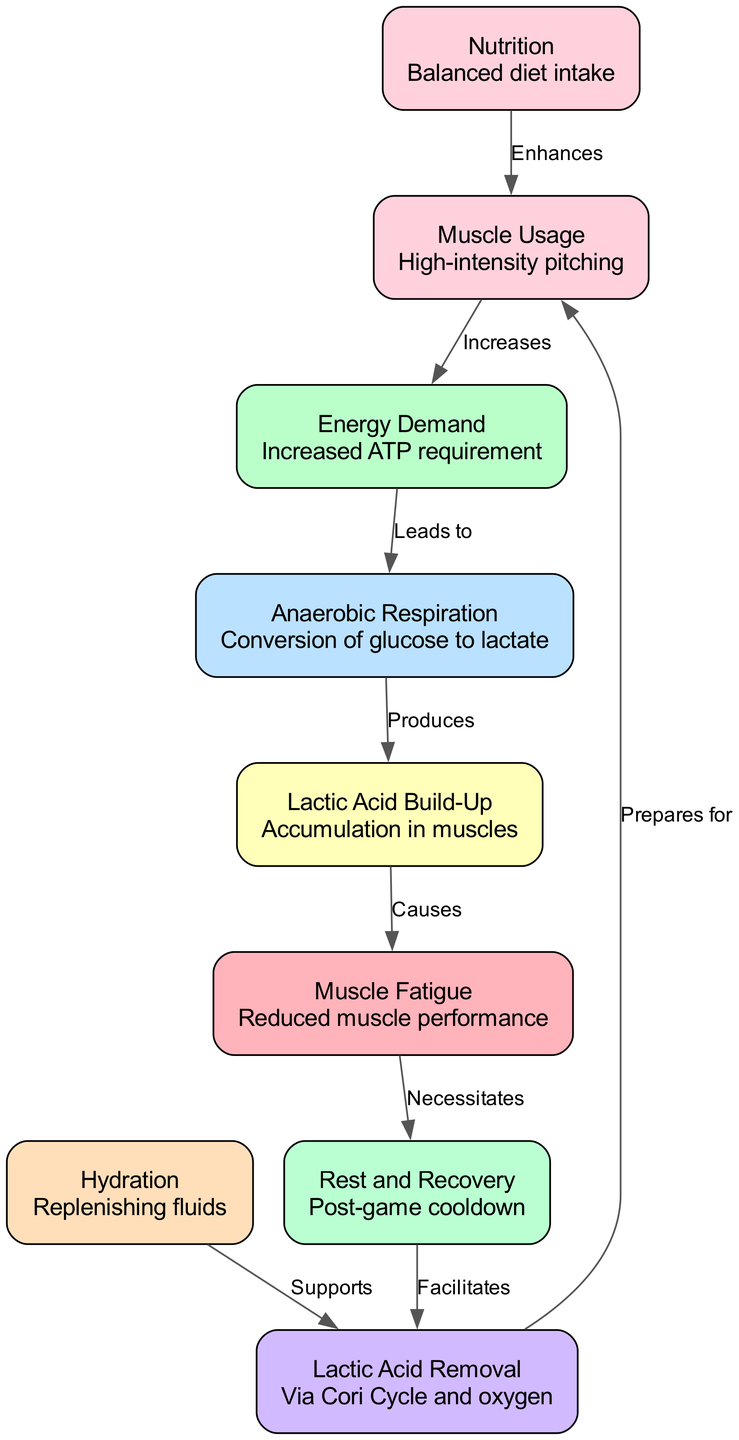What is the first node in the diagram? The first node is "Muscle Usage," which represents high-intensity pitching. The nodes are presented in an order defined by the relationships illustrated in the edges.
Answer: Muscle Usage How many nodes are in the diagram? The diagram contains 9 nodes that represent different aspects of muscle fatigue and recovery related to baseball pitchers. Each node corresponds to a unique concept in the process illustrated.
Answer: 9 What causes lactic acid build-up? Lactic acid build-up is caused by anaerobic respiration, which is the conversion of glucose to lactate during high-energy demands in muscle usage. The arrows in the diagram indicate the flow of influence leading to lactic acid formation.
Answer: Anaerobic Respiration What supports lactic acid clearance? Lactic acid clearance is supported by hydration, which aids in the process of removing lactic acid from the muscles. The diagram explicitly connects these two nodes, showing their relationship.
Answer: Hydration What is produced from anaerobic respiration? Anaerobic respiration produces lactic acid as a byproduct when glucose is converted under high-energy demand conditions during pitching. This is highlighted in the diagram showing the flow from anaerobic respiration to lactic acid.
Answer: Lactic Acid How does rest and recovery relate to muscle fatigue? Rest and recovery is necessitated by muscle fatigue, indicating that when muscle fatigue occurs, it is essential to allow time for rest and recovery to facilitate the clearance process and prepare for further muscle usage. The relationship is depicted by the arrow connecting these two nodes.
Answer: Necessitates Which node enhances muscle usage? Nutrition enhances muscle usage by providing a balanced diet that supplies the necessary energy and nutrients for performing at high levels during pitching. This connection is outlined in the diagram.
Answer: Nutrition What facilitates lactic acid clearance? Rest and recovery facilitates lactic acid clearance, as during the recovery phase, processes occur that help remove lactic acid from the muscles. The diagram shows a directional relationship from rest and recovery to lactic acid clearance.
Answer: Facilitates 